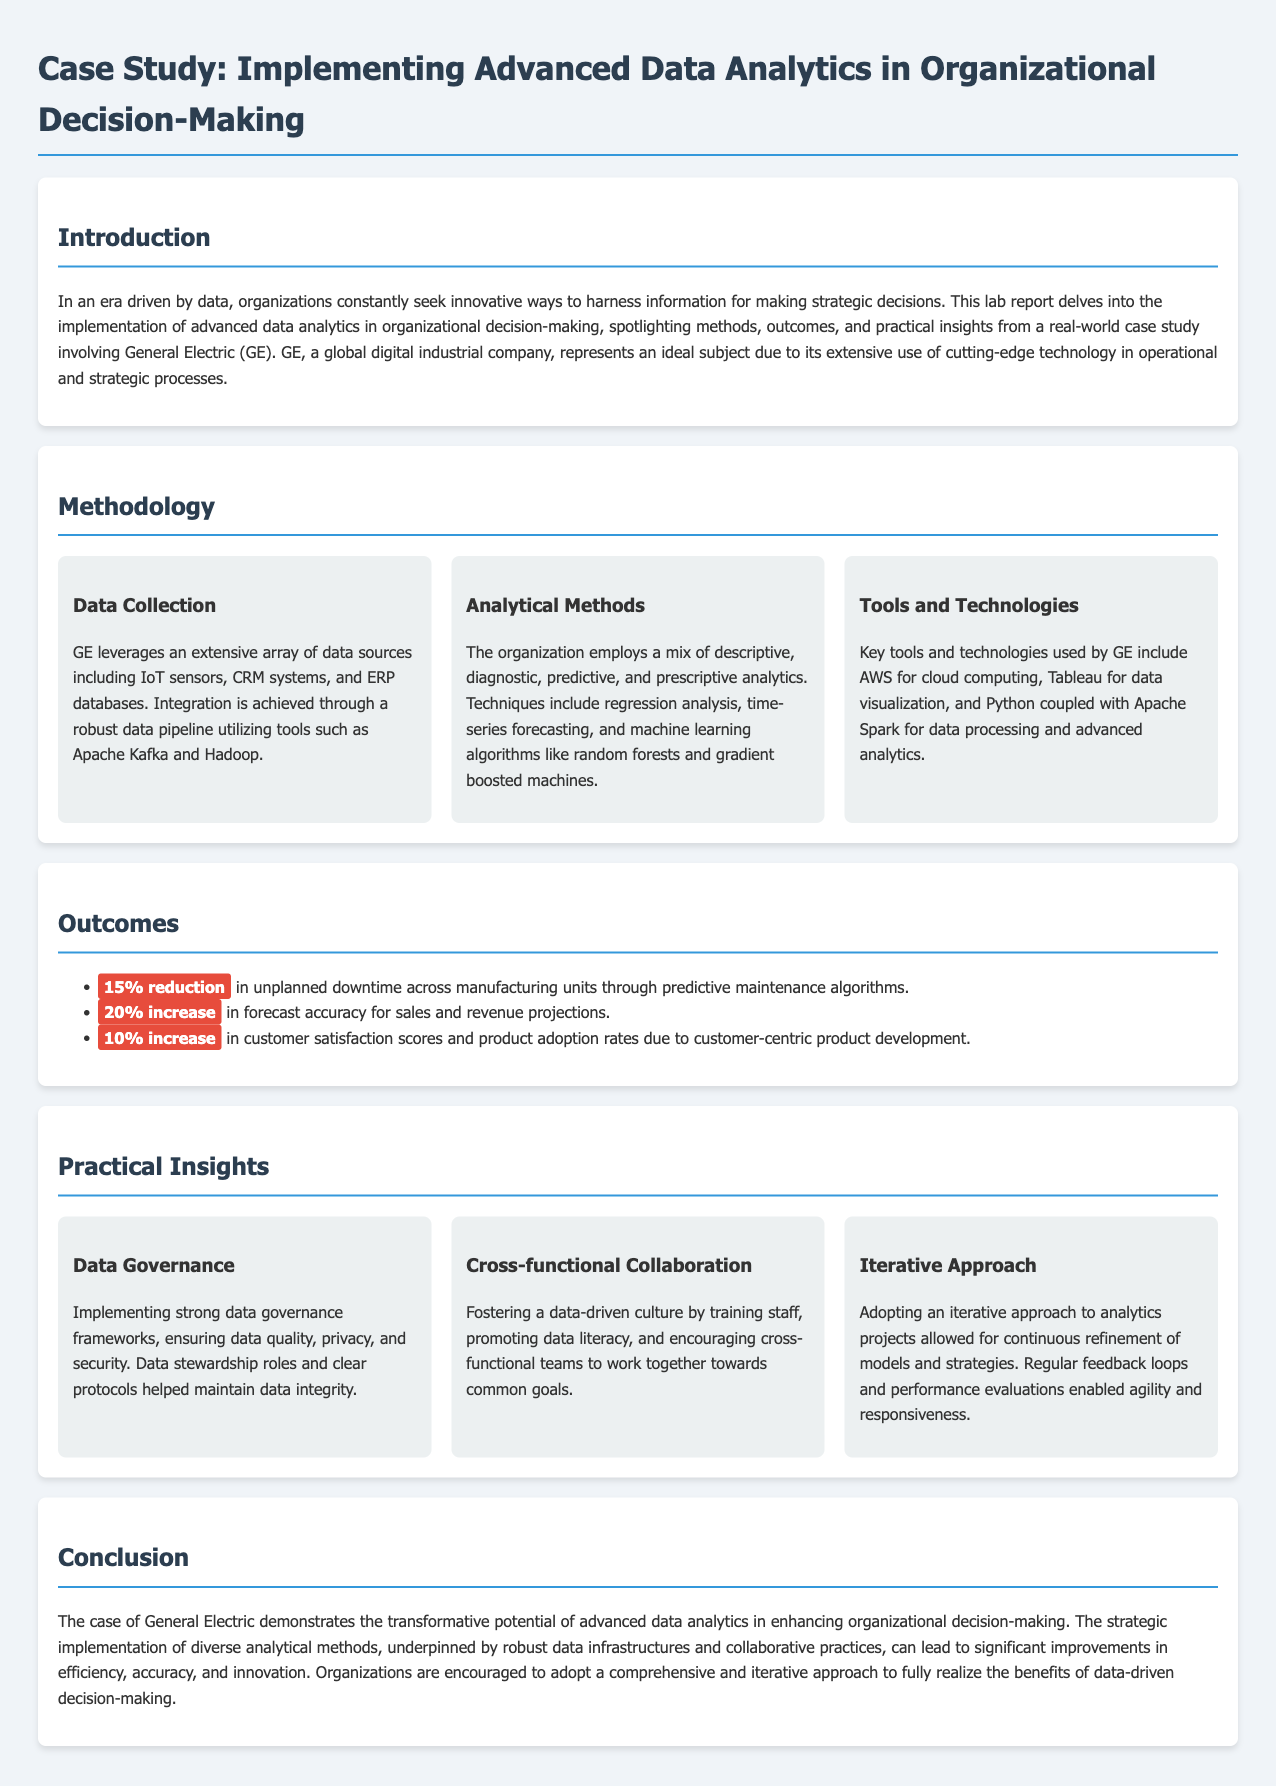What company does the case study focus on? The case study focuses on General Electric (GE), as mentioned in the introduction.
Answer: General Electric What analytical methods does GE employ? GE employs descriptive, diagnostic, predictive, and prescriptive analytics, as listed in the methodology section.
Answer: Descriptive, diagnostic, predictive, prescriptive What is the percentage increase in forecast accuracy for sales? The document states a 20% increase in forecast accuracy for sales and revenue projections in the outcomes section.
Answer: 20% What tool is used by GE for data visualization? The methodology section specifies that Tableau is used for data visualization by GE.
Answer: Tableau What approach does GE adopt for their analytics projects? An iterative approach is mentioned in the practical insights section as a strategy used by GE.
Answer: Iterative approach What is one of the key outcomes related to unplanned downtime? The document states a 15% reduction in unplanned downtime across manufacturing units due to predictive maintenance algorithms.
Answer: 15% reduction What aspect of GE's strategy helps maintain data integrity? The document highlights the implementation of strong data governance frameworks as a key aspect for maintaining data integrity.
Answer: Data governance frameworks What is emphasized as important for fostering a data-driven culture? Training staff and promoting data literacy are emphasized for fostering a data-driven culture.
Answer: Training staff, promoting data literacy 